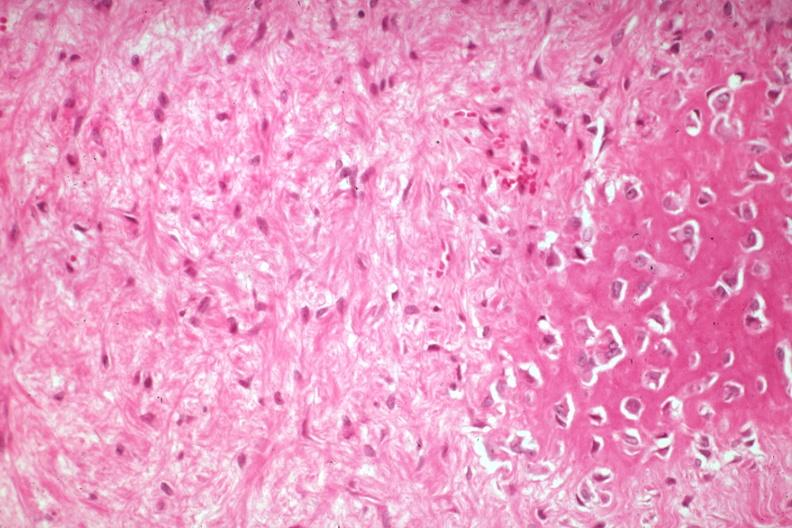what is present?
Answer the question using a single word or phrase. Joints 